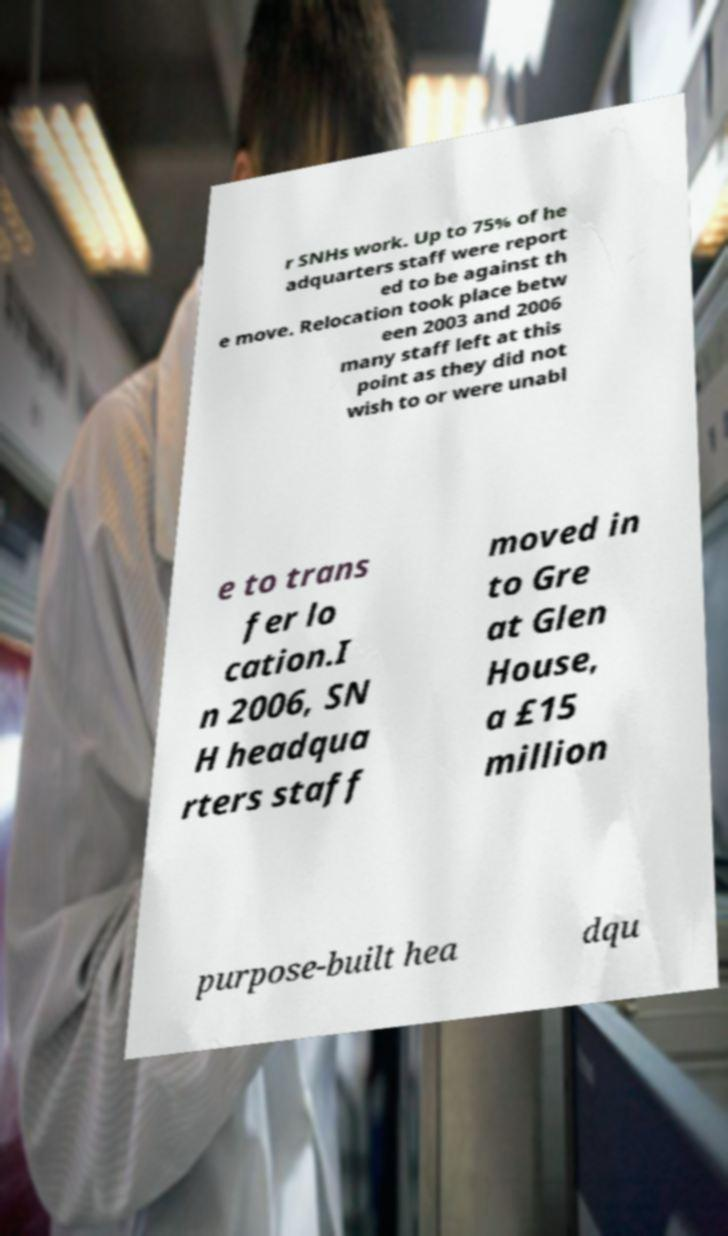Could you assist in decoding the text presented in this image and type it out clearly? r SNHs work. Up to 75% of he adquarters staff were report ed to be against th e move. Relocation took place betw een 2003 and 2006 many staff left at this point as they did not wish to or were unabl e to trans fer lo cation.I n 2006, SN H headqua rters staff moved in to Gre at Glen House, a £15 million purpose-built hea dqu 